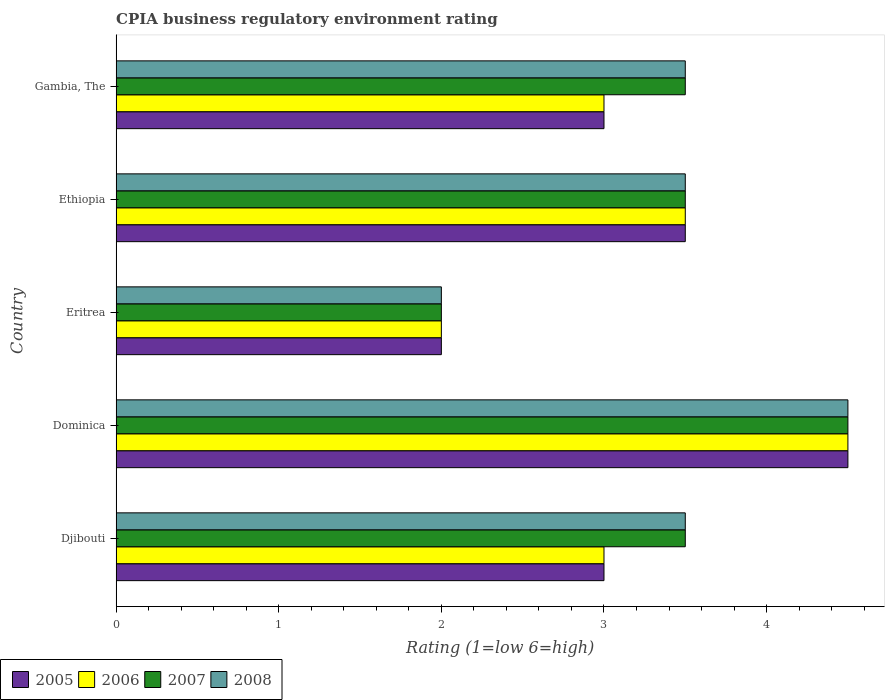How many different coloured bars are there?
Keep it short and to the point. 4. How many groups of bars are there?
Your answer should be compact. 5. Are the number of bars on each tick of the Y-axis equal?
Provide a succinct answer. Yes. How many bars are there on the 3rd tick from the bottom?
Your response must be concise. 4. What is the label of the 1st group of bars from the top?
Offer a very short reply. Gambia, The. In how many cases, is the number of bars for a given country not equal to the number of legend labels?
Keep it short and to the point. 0. Across all countries, what is the maximum CPIA rating in 2006?
Give a very brief answer. 4.5. In which country was the CPIA rating in 2006 maximum?
Make the answer very short. Dominica. In which country was the CPIA rating in 2007 minimum?
Give a very brief answer. Eritrea. What is the difference between the CPIA rating in 2008 in Dominica and that in Gambia, The?
Keep it short and to the point. 1. What is the average CPIA rating in 2007 per country?
Offer a very short reply. 3.4. What is the ratio of the CPIA rating in 2008 in Djibouti to that in Gambia, The?
Your answer should be compact. 1. Is the CPIA rating in 2005 in Ethiopia less than that in Gambia, The?
Your answer should be very brief. No. What is the difference between the highest and the lowest CPIA rating in 2005?
Make the answer very short. 2.5. What does the 4th bar from the top in Djibouti represents?
Give a very brief answer. 2005. What does the 3rd bar from the bottom in Gambia, The represents?
Your response must be concise. 2007. Is it the case that in every country, the sum of the CPIA rating in 2008 and CPIA rating in 2005 is greater than the CPIA rating in 2006?
Your response must be concise. Yes. How many bars are there?
Give a very brief answer. 20. Are the values on the major ticks of X-axis written in scientific E-notation?
Keep it short and to the point. No. Does the graph contain any zero values?
Keep it short and to the point. No. How are the legend labels stacked?
Your response must be concise. Horizontal. What is the title of the graph?
Offer a terse response. CPIA business regulatory environment rating. Does "2003" appear as one of the legend labels in the graph?
Provide a short and direct response. No. What is the Rating (1=low 6=high) in 2005 in Djibouti?
Your answer should be compact. 3. What is the Rating (1=low 6=high) of 2006 in Djibouti?
Give a very brief answer. 3. What is the Rating (1=low 6=high) of 2008 in Djibouti?
Your answer should be compact. 3.5. What is the Rating (1=low 6=high) of 2005 in Dominica?
Make the answer very short. 4.5. What is the Rating (1=low 6=high) in 2006 in Dominica?
Give a very brief answer. 4.5. What is the Rating (1=low 6=high) of 2007 in Dominica?
Provide a succinct answer. 4.5. What is the Rating (1=low 6=high) in 2008 in Dominica?
Make the answer very short. 4.5. What is the Rating (1=low 6=high) in 2005 in Eritrea?
Give a very brief answer. 2. What is the Rating (1=low 6=high) of 2006 in Eritrea?
Make the answer very short. 2. What is the Rating (1=low 6=high) of 2008 in Ethiopia?
Offer a terse response. 3.5. What is the Rating (1=low 6=high) of 2006 in Gambia, The?
Provide a short and direct response. 3. What is the Rating (1=low 6=high) of 2007 in Gambia, The?
Provide a succinct answer. 3.5. Across all countries, what is the maximum Rating (1=low 6=high) in 2006?
Offer a very short reply. 4.5. Across all countries, what is the maximum Rating (1=low 6=high) in 2007?
Give a very brief answer. 4.5. Across all countries, what is the maximum Rating (1=low 6=high) of 2008?
Your answer should be compact. 4.5. Across all countries, what is the minimum Rating (1=low 6=high) of 2005?
Your response must be concise. 2. What is the total Rating (1=low 6=high) of 2007 in the graph?
Offer a very short reply. 17. What is the total Rating (1=low 6=high) in 2008 in the graph?
Offer a terse response. 17. What is the difference between the Rating (1=low 6=high) in 2005 in Djibouti and that in Dominica?
Your answer should be compact. -1.5. What is the difference between the Rating (1=low 6=high) of 2007 in Djibouti and that in Dominica?
Offer a very short reply. -1. What is the difference between the Rating (1=low 6=high) in 2008 in Djibouti and that in Eritrea?
Your response must be concise. 1.5. What is the difference between the Rating (1=low 6=high) of 2008 in Djibouti and that in Ethiopia?
Ensure brevity in your answer.  0. What is the difference between the Rating (1=low 6=high) in 2005 in Djibouti and that in Gambia, The?
Offer a very short reply. 0. What is the difference between the Rating (1=low 6=high) in 2006 in Djibouti and that in Gambia, The?
Offer a very short reply. 0. What is the difference between the Rating (1=low 6=high) in 2008 in Djibouti and that in Gambia, The?
Your response must be concise. 0. What is the difference between the Rating (1=low 6=high) in 2005 in Dominica and that in Eritrea?
Your response must be concise. 2.5. What is the difference between the Rating (1=low 6=high) of 2006 in Dominica and that in Ethiopia?
Offer a terse response. 1. What is the difference between the Rating (1=low 6=high) of 2007 in Dominica and that in Ethiopia?
Your response must be concise. 1. What is the difference between the Rating (1=low 6=high) in 2008 in Dominica and that in Ethiopia?
Give a very brief answer. 1. What is the difference between the Rating (1=low 6=high) in 2005 in Dominica and that in Gambia, The?
Offer a terse response. 1.5. What is the difference between the Rating (1=low 6=high) in 2007 in Dominica and that in Gambia, The?
Give a very brief answer. 1. What is the difference between the Rating (1=low 6=high) of 2008 in Eritrea and that in Ethiopia?
Provide a succinct answer. -1.5. What is the difference between the Rating (1=low 6=high) in 2007 in Eritrea and that in Gambia, The?
Offer a terse response. -1.5. What is the difference between the Rating (1=low 6=high) in 2006 in Ethiopia and that in Gambia, The?
Your answer should be very brief. 0.5. What is the difference between the Rating (1=low 6=high) of 2006 in Djibouti and the Rating (1=low 6=high) of 2008 in Dominica?
Your answer should be compact. -1.5. What is the difference between the Rating (1=low 6=high) in 2005 in Djibouti and the Rating (1=low 6=high) in 2006 in Eritrea?
Give a very brief answer. 1. What is the difference between the Rating (1=low 6=high) of 2005 in Djibouti and the Rating (1=low 6=high) of 2008 in Eritrea?
Provide a succinct answer. 1. What is the difference between the Rating (1=low 6=high) of 2006 in Djibouti and the Rating (1=low 6=high) of 2007 in Eritrea?
Keep it short and to the point. 1. What is the difference between the Rating (1=low 6=high) of 2005 in Djibouti and the Rating (1=low 6=high) of 2006 in Ethiopia?
Provide a short and direct response. -0.5. What is the difference between the Rating (1=low 6=high) in 2005 in Djibouti and the Rating (1=low 6=high) in 2007 in Ethiopia?
Offer a terse response. -0.5. What is the difference between the Rating (1=low 6=high) in 2005 in Djibouti and the Rating (1=low 6=high) in 2008 in Ethiopia?
Offer a terse response. -0.5. What is the difference between the Rating (1=low 6=high) in 2006 in Djibouti and the Rating (1=low 6=high) in 2008 in Ethiopia?
Keep it short and to the point. -0.5. What is the difference between the Rating (1=low 6=high) of 2005 in Djibouti and the Rating (1=low 6=high) of 2006 in Gambia, The?
Ensure brevity in your answer.  0. What is the difference between the Rating (1=low 6=high) of 2005 in Djibouti and the Rating (1=low 6=high) of 2008 in Gambia, The?
Your answer should be very brief. -0.5. What is the difference between the Rating (1=low 6=high) in 2006 in Djibouti and the Rating (1=low 6=high) in 2007 in Gambia, The?
Ensure brevity in your answer.  -0.5. What is the difference between the Rating (1=low 6=high) in 2007 in Djibouti and the Rating (1=low 6=high) in 2008 in Gambia, The?
Make the answer very short. 0. What is the difference between the Rating (1=low 6=high) of 2007 in Dominica and the Rating (1=low 6=high) of 2008 in Eritrea?
Your answer should be compact. 2.5. What is the difference between the Rating (1=low 6=high) of 2005 in Dominica and the Rating (1=low 6=high) of 2006 in Ethiopia?
Give a very brief answer. 1. What is the difference between the Rating (1=low 6=high) in 2005 in Dominica and the Rating (1=low 6=high) in 2008 in Ethiopia?
Make the answer very short. 1. What is the difference between the Rating (1=low 6=high) of 2005 in Dominica and the Rating (1=low 6=high) of 2006 in Gambia, The?
Your response must be concise. 1.5. What is the difference between the Rating (1=low 6=high) in 2005 in Dominica and the Rating (1=low 6=high) in 2007 in Gambia, The?
Your answer should be compact. 1. What is the difference between the Rating (1=low 6=high) of 2005 in Dominica and the Rating (1=low 6=high) of 2008 in Gambia, The?
Provide a short and direct response. 1. What is the difference between the Rating (1=low 6=high) in 2006 in Dominica and the Rating (1=low 6=high) in 2008 in Gambia, The?
Offer a terse response. 1. What is the difference between the Rating (1=low 6=high) of 2007 in Dominica and the Rating (1=low 6=high) of 2008 in Gambia, The?
Provide a short and direct response. 1. What is the difference between the Rating (1=low 6=high) of 2005 in Eritrea and the Rating (1=low 6=high) of 2007 in Gambia, The?
Ensure brevity in your answer.  -1.5. What is the difference between the Rating (1=low 6=high) of 2006 in Eritrea and the Rating (1=low 6=high) of 2008 in Gambia, The?
Ensure brevity in your answer.  -1.5. What is the difference between the Rating (1=low 6=high) of 2005 in Ethiopia and the Rating (1=low 6=high) of 2008 in Gambia, The?
Offer a terse response. 0. What is the difference between the Rating (1=low 6=high) of 2006 in Ethiopia and the Rating (1=low 6=high) of 2008 in Gambia, The?
Keep it short and to the point. 0. What is the difference between the Rating (1=low 6=high) of 2007 in Ethiopia and the Rating (1=low 6=high) of 2008 in Gambia, The?
Give a very brief answer. 0. What is the average Rating (1=low 6=high) in 2005 per country?
Offer a very short reply. 3.2. What is the average Rating (1=low 6=high) in 2006 per country?
Keep it short and to the point. 3.2. What is the average Rating (1=low 6=high) in 2008 per country?
Keep it short and to the point. 3.4. What is the difference between the Rating (1=low 6=high) of 2005 and Rating (1=low 6=high) of 2008 in Djibouti?
Offer a terse response. -0.5. What is the difference between the Rating (1=low 6=high) in 2006 and Rating (1=low 6=high) in 2008 in Djibouti?
Provide a succinct answer. -0.5. What is the difference between the Rating (1=low 6=high) of 2007 and Rating (1=low 6=high) of 2008 in Djibouti?
Make the answer very short. 0. What is the difference between the Rating (1=low 6=high) of 2005 and Rating (1=low 6=high) of 2006 in Dominica?
Provide a short and direct response. 0. What is the difference between the Rating (1=low 6=high) in 2006 and Rating (1=low 6=high) in 2007 in Dominica?
Your response must be concise. 0. What is the difference between the Rating (1=low 6=high) of 2007 and Rating (1=low 6=high) of 2008 in Dominica?
Ensure brevity in your answer.  0. What is the difference between the Rating (1=low 6=high) in 2005 and Rating (1=low 6=high) in 2006 in Eritrea?
Your answer should be very brief. 0. What is the difference between the Rating (1=low 6=high) in 2007 and Rating (1=low 6=high) in 2008 in Eritrea?
Provide a succinct answer. 0. What is the difference between the Rating (1=low 6=high) in 2005 and Rating (1=low 6=high) in 2007 in Ethiopia?
Your answer should be compact. 0. What is the difference between the Rating (1=low 6=high) of 2006 and Rating (1=low 6=high) of 2007 in Ethiopia?
Your answer should be compact. 0. What is the difference between the Rating (1=low 6=high) in 2006 and Rating (1=low 6=high) in 2008 in Ethiopia?
Your response must be concise. 0. What is the difference between the Rating (1=low 6=high) of 2007 and Rating (1=low 6=high) of 2008 in Ethiopia?
Offer a terse response. 0. What is the difference between the Rating (1=low 6=high) in 2005 and Rating (1=low 6=high) in 2008 in Gambia, The?
Offer a very short reply. -0.5. What is the difference between the Rating (1=low 6=high) of 2006 and Rating (1=low 6=high) of 2007 in Gambia, The?
Ensure brevity in your answer.  -0.5. What is the difference between the Rating (1=low 6=high) in 2006 and Rating (1=low 6=high) in 2008 in Gambia, The?
Your answer should be very brief. -0.5. What is the ratio of the Rating (1=low 6=high) in 2005 in Djibouti to that in Dominica?
Provide a succinct answer. 0.67. What is the ratio of the Rating (1=low 6=high) in 2006 in Djibouti to that in Dominica?
Provide a short and direct response. 0.67. What is the ratio of the Rating (1=low 6=high) in 2006 in Djibouti to that in Ethiopia?
Give a very brief answer. 0.86. What is the ratio of the Rating (1=low 6=high) in 2008 in Djibouti to that in Ethiopia?
Offer a terse response. 1. What is the ratio of the Rating (1=low 6=high) in 2005 in Dominica to that in Eritrea?
Provide a succinct answer. 2.25. What is the ratio of the Rating (1=low 6=high) in 2006 in Dominica to that in Eritrea?
Give a very brief answer. 2.25. What is the ratio of the Rating (1=low 6=high) in 2007 in Dominica to that in Eritrea?
Ensure brevity in your answer.  2.25. What is the ratio of the Rating (1=low 6=high) in 2008 in Dominica to that in Eritrea?
Your answer should be very brief. 2.25. What is the ratio of the Rating (1=low 6=high) of 2005 in Dominica to that in Ethiopia?
Your answer should be very brief. 1.29. What is the ratio of the Rating (1=low 6=high) of 2008 in Dominica to that in Ethiopia?
Provide a succinct answer. 1.29. What is the ratio of the Rating (1=low 6=high) in 2006 in Eritrea to that in Ethiopia?
Give a very brief answer. 0.57. What is the ratio of the Rating (1=low 6=high) in 2007 in Eritrea to that in Ethiopia?
Give a very brief answer. 0.57. What is the ratio of the Rating (1=low 6=high) of 2008 in Eritrea to that in Ethiopia?
Offer a terse response. 0.57. What is the ratio of the Rating (1=low 6=high) in 2006 in Eritrea to that in Gambia, The?
Keep it short and to the point. 0.67. What is the ratio of the Rating (1=low 6=high) of 2006 in Ethiopia to that in Gambia, The?
Provide a succinct answer. 1.17. What is the ratio of the Rating (1=low 6=high) of 2007 in Ethiopia to that in Gambia, The?
Keep it short and to the point. 1. What is the difference between the highest and the second highest Rating (1=low 6=high) in 2006?
Your response must be concise. 1. What is the difference between the highest and the second highest Rating (1=low 6=high) of 2007?
Ensure brevity in your answer.  1. What is the difference between the highest and the second highest Rating (1=low 6=high) of 2008?
Your answer should be very brief. 1. 